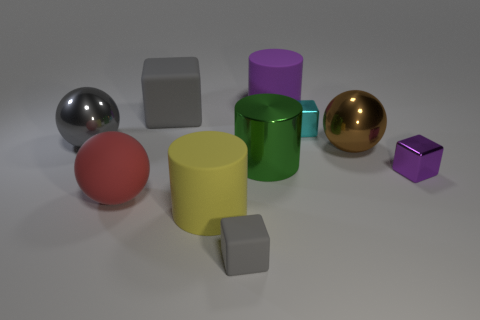Subtract all cyan cubes. How many cubes are left? 3 Subtract all tiny gray matte cubes. How many cubes are left? 3 Subtract all brown cubes. Subtract all purple cylinders. How many cubes are left? 4 Subtract all spheres. How many objects are left? 7 Subtract 1 purple cylinders. How many objects are left? 9 Subtract all shiny blocks. Subtract all red rubber spheres. How many objects are left? 7 Add 1 large blocks. How many large blocks are left? 2 Add 6 small green balls. How many small green balls exist? 6 